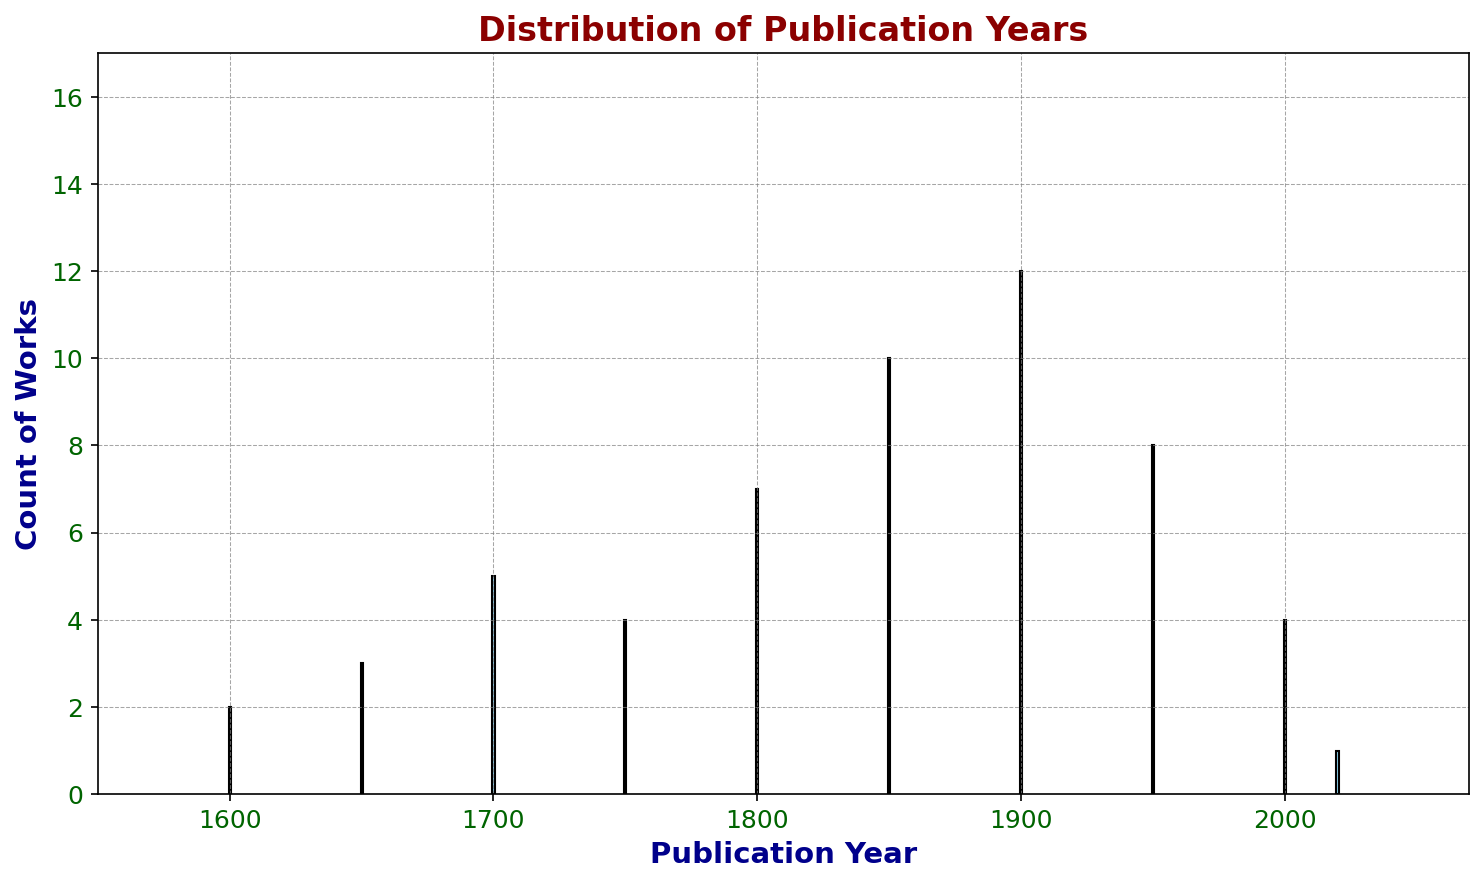Which publication year has the highest count of works studied? The bar with the highest value represents the publication year with the most works studied. The highest bar is at 1900.
Answer: 1900 How many works were published between 1600 and 1750 (inclusive)? Add the counts of the years 1600, 1650, 1700, and 1750. The counts are 2, 3, 5, and 4, respectively. Thus, 2 + 3 + 5 + 4 = 14.
Answer: 14 Which period has more works studied: 1800-1850 or 1950-2000? Compare the total counts for the ranges 1800 to 1850 and 1950 to 2000. For 1800-1850, add 7 (1800) + 10 (1850) = 17. For 1950-2000, add 8 (1950) + 4 (2000) = 12.
Answer: 1800-1850 What's the average count of works studied per time period across all given years? Sum all the counts and divide by the number of years. The sum is 2 + 3 + 5 + 4 + 7 + 10 + 12 + 8 + 4 + 1 = 56. There are 10 years, so 56 / 10 = 5.6.
Answer: 5.6 During which century are works more prevalent: 17th century or 19th century? Add the counts of works for the 17th century (1600 and 1650) and for the 19th century (1800 and 1850). 2 + 3 = 5 for the 17th century and 7 + 10 = 17 for the 19th century.
Answer: 19th century Which publication year has the least count of works studied? The bar with the smallest value represents the publication year with the fewest works studied. The lowest bar is at 2020.
Answer: 2020 What is the difference in the count of works between 1900 and 2020? Subtract the count at 2020 from the count at 1900. The difference is 12 (1900) - 1 (2020) = 11.
Answer: 11 Is the number of works studied higher in 1850 or 2000? Compare the height of the bars for the years 1850 and 2000. The count for 1850 is 10, while for 2000, it is 4.
Answer: 1850 What is the percentage increase in the number of works from 1750 to 1850? Calculate the percentage increase using the formula: ((New Value - Old Value) / Old Value) * 100. So, ((10 - 4) / 4) * 100 = 150%.
Answer: 150% Does any publication year have a count that equals the average count across all given years? The average count has been calculated as 5.6. Inspect all the bars to see if any have a count of 5. The year 1700 has exactly 5 works.
Answer: Yes 